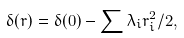<formula> <loc_0><loc_0><loc_500><loc_500>\delta ( r ) = \delta ( 0 ) - \sum \lambda _ { i } r _ { i } ^ { 2 } / 2 ,</formula> 